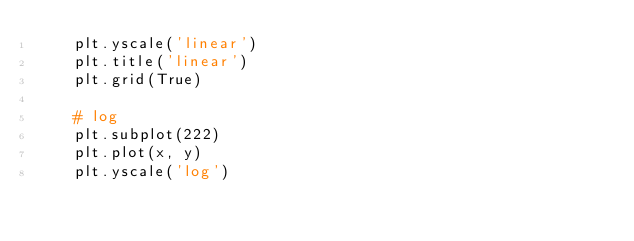Convert code to text. <code><loc_0><loc_0><loc_500><loc_500><_Python_>    plt.yscale('linear')
    plt.title('linear')
    plt.grid(True)

    # log
    plt.subplot(222)
    plt.plot(x, y)
    plt.yscale('log')</code> 